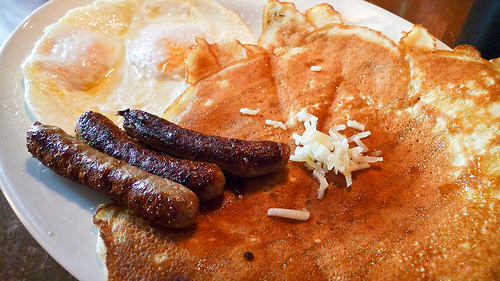<image>
Is there a sausage on the pancake? Yes. Looking at the image, I can see the sausage is positioned on top of the pancake, with the pancake providing support. Is there a plastic glass next to the waiter? No. The plastic glass is not positioned next to the waiter. They are located in different areas of the scene. 